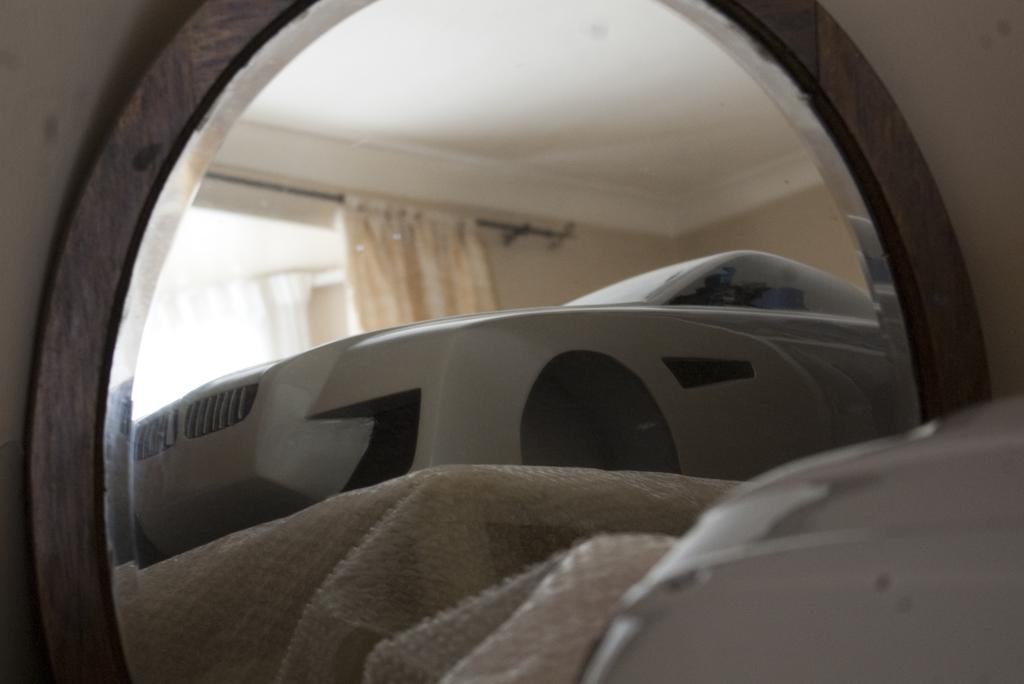What type of space is depicted in the image? The image is of a room. What is located in the foreground of the room? There is a mirror in the foreground of the room. What does the mirror reflect in the image? The mirror reflects a cover and an object, as well as a curtain and a wall. How many ducks are visible in the image? There are no ducks present in the image. What type of knee can be seen in the image? There is no knee visible in the image. 